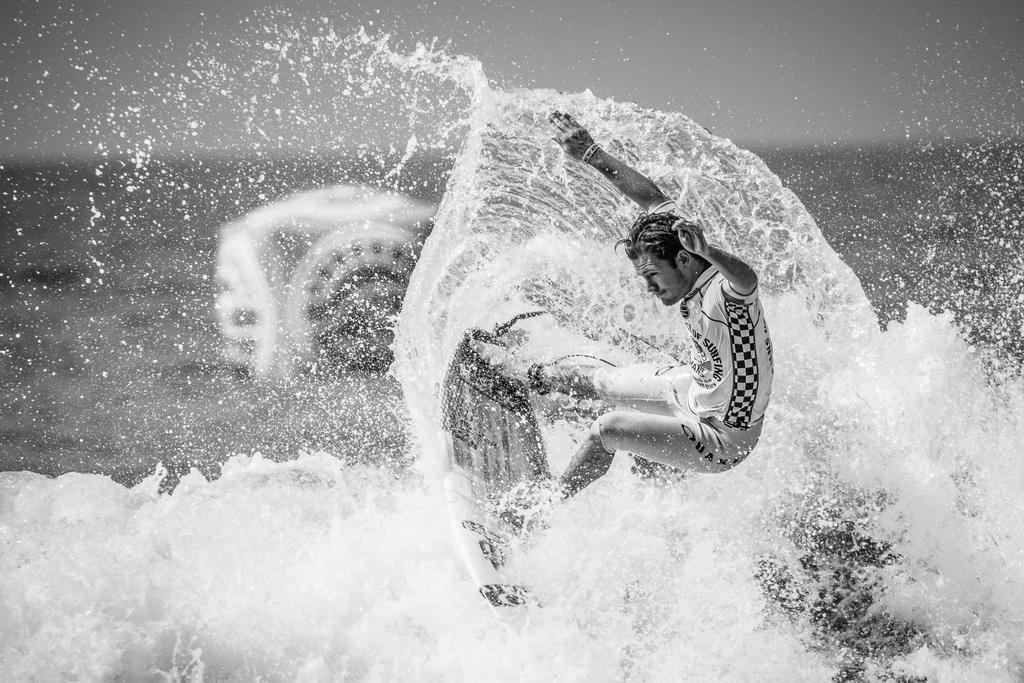Who is the main subject in the image? There is a man in the image. What is the man doing in the image? The man is standing on a surfboard and surfing on water. What can be seen in the background of the image? The sky is visible in the background of the image. What type of chalk is the man using to draw on the surfboard in the image? There is no chalk present in the image, and the man is not drawing on the surfboard. 